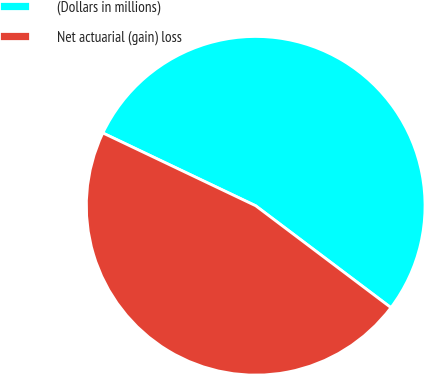Convert chart to OTSL. <chart><loc_0><loc_0><loc_500><loc_500><pie_chart><fcel>(Dollars in millions)<fcel>Net actuarial (gain) loss<nl><fcel>53.2%<fcel>46.8%<nl></chart> 